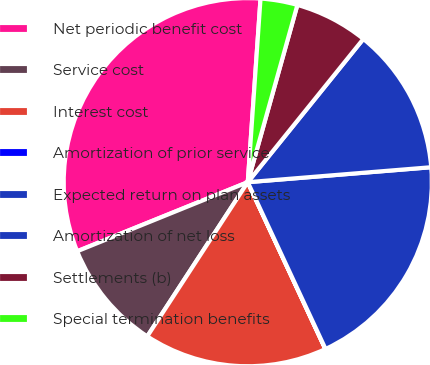Convert chart to OTSL. <chart><loc_0><loc_0><loc_500><loc_500><pie_chart><fcel>Net periodic benefit cost<fcel>Service cost<fcel>Interest cost<fcel>Amortization of prior service<fcel>Expected return on plan assets<fcel>Amortization of net loss<fcel>Settlements (b)<fcel>Special termination benefits<nl><fcel>32.23%<fcel>9.68%<fcel>16.12%<fcel>0.02%<fcel>19.35%<fcel>12.9%<fcel>6.46%<fcel>3.24%<nl></chart> 